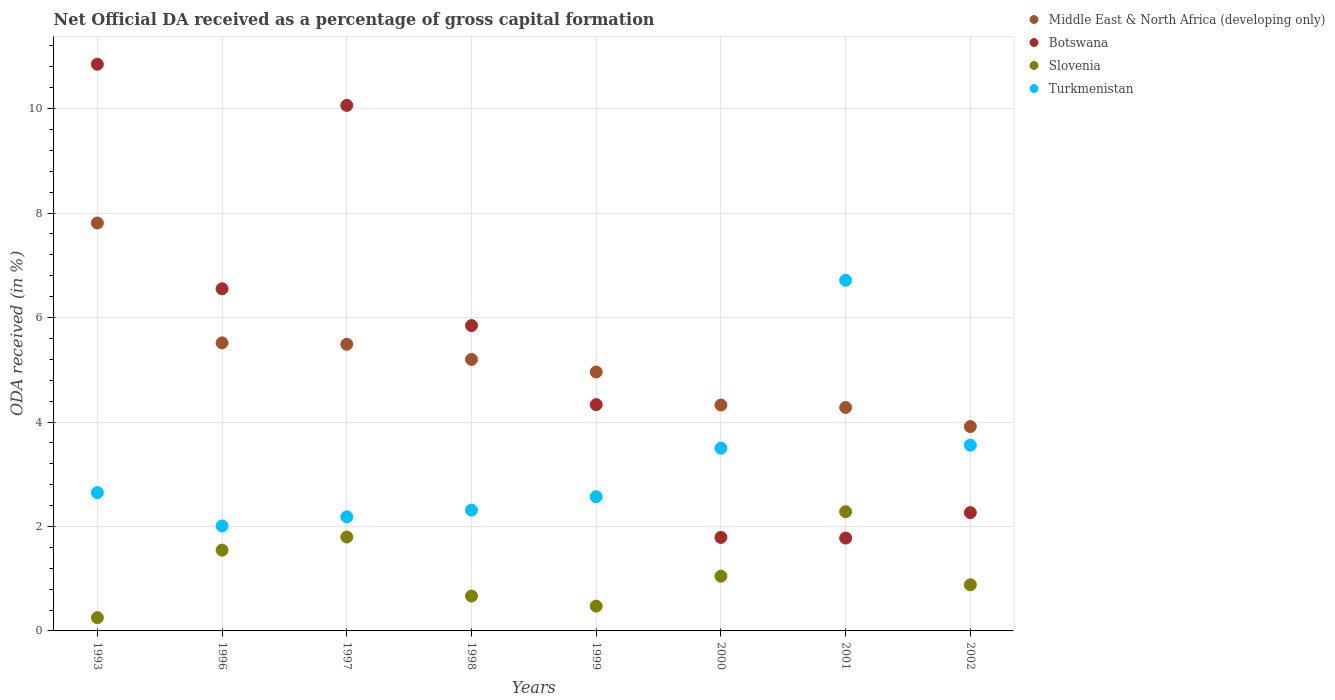Is the number of dotlines equal to the number of legend labels?
Your answer should be very brief. Yes. What is the net ODA received in Slovenia in 1993?
Your answer should be compact. 0.25. Across all years, what is the maximum net ODA received in Middle East & North Africa (developing only)?
Make the answer very short. 7.81. Across all years, what is the minimum net ODA received in Turkmenistan?
Provide a short and direct response. 2.01. In which year was the net ODA received in Middle East & North Africa (developing only) maximum?
Make the answer very short. 1993. In which year was the net ODA received in Turkmenistan minimum?
Provide a short and direct response. 1996. What is the total net ODA received in Slovenia in the graph?
Make the answer very short. 8.95. What is the difference between the net ODA received in Botswana in 1997 and that in 1998?
Ensure brevity in your answer.  4.22. What is the difference between the net ODA received in Middle East & North Africa (developing only) in 1993 and the net ODA received in Botswana in 2002?
Keep it short and to the point. 5.55. What is the average net ODA received in Turkmenistan per year?
Give a very brief answer. 3.19. In the year 1998, what is the difference between the net ODA received in Slovenia and net ODA received in Botswana?
Keep it short and to the point. -5.18. What is the ratio of the net ODA received in Slovenia in 1996 to that in 2000?
Keep it short and to the point. 1.48. Is the difference between the net ODA received in Slovenia in 1997 and 2001 greater than the difference between the net ODA received in Botswana in 1997 and 2001?
Keep it short and to the point. No. What is the difference between the highest and the second highest net ODA received in Slovenia?
Provide a succinct answer. 0.48. What is the difference between the highest and the lowest net ODA received in Turkmenistan?
Your response must be concise. 4.7. Is it the case that in every year, the sum of the net ODA received in Middle East & North Africa (developing only) and net ODA received in Botswana  is greater than the net ODA received in Slovenia?
Ensure brevity in your answer.  Yes. Is the net ODA received in Turkmenistan strictly greater than the net ODA received in Middle East & North Africa (developing only) over the years?
Make the answer very short. No. How many dotlines are there?
Offer a terse response. 4. What is the difference between two consecutive major ticks on the Y-axis?
Make the answer very short. 2. Are the values on the major ticks of Y-axis written in scientific E-notation?
Offer a terse response. No. Does the graph contain any zero values?
Your answer should be very brief. No. How many legend labels are there?
Your answer should be compact. 4. What is the title of the graph?
Ensure brevity in your answer.  Net Official DA received as a percentage of gross capital formation. What is the label or title of the X-axis?
Your answer should be very brief. Years. What is the label or title of the Y-axis?
Your answer should be compact. ODA received (in %). What is the ODA received (in %) of Middle East & North Africa (developing only) in 1993?
Ensure brevity in your answer.  7.81. What is the ODA received (in %) of Botswana in 1993?
Provide a succinct answer. 10.85. What is the ODA received (in %) of Slovenia in 1993?
Offer a very short reply. 0.25. What is the ODA received (in %) in Turkmenistan in 1993?
Make the answer very short. 2.65. What is the ODA received (in %) of Middle East & North Africa (developing only) in 1996?
Keep it short and to the point. 5.52. What is the ODA received (in %) of Botswana in 1996?
Offer a terse response. 6.55. What is the ODA received (in %) of Slovenia in 1996?
Give a very brief answer. 1.55. What is the ODA received (in %) in Turkmenistan in 1996?
Keep it short and to the point. 2.01. What is the ODA received (in %) of Middle East & North Africa (developing only) in 1997?
Give a very brief answer. 5.49. What is the ODA received (in %) of Botswana in 1997?
Ensure brevity in your answer.  10.06. What is the ODA received (in %) of Slovenia in 1997?
Ensure brevity in your answer.  1.8. What is the ODA received (in %) in Turkmenistan in 1997?
Offer a very short reply. 2.18. What is the ODA received (in %) in Middle East & North Africa (developing only) in 1998?
Give a very brief answer. 5.2. What is the ODA received (in %) of Botswana in 1998?
Provide a short and direct response. 5.85. What is the ODA received (in %) in Slovenia in 1998?
Ensure brevity in your answer.  0.67. What is the ODA received (in %) of Turkmenistan in 1998?
Provide a succinct answer. 2.31. What is the ODA received (in %) of Middle East & North Africa (developing only) in 1999?
Provide a short and direct response. 4.96. What is the ODA received (in %) in Botswana in 1999?
Make the answer very short. 4.33. What is the ODA received (in %) of Slovenia in 1999?
Keep it short and to the point. 0.47. What is the ODA received (in %) in Turkmenistan in 1999?
Make the answer very short. 2.57. What is the ODA received (in %) in Middle East & North Africa (developing only) in 2000?
Make the answer very short. 4.33. What is the ODA received (in %) in Botswana in 2000?
Make the answer very short. 1.79. What is the ODA received (in %) in Slovenia in 2000?
Provide a short and direct response. 1.05. What is the ODA received (in %) in Turkmenistan in 2000?
Give a very brief answer. 3.5. What is the ODA received (in %) of Middle East & North Africa (developing only) in 2001?
Provide a short and direct response. 4.28. What is the ODA received (in %) in Botswana in 2001?
Provide a short and direct response. 1.78. What is the ODA received (in %) of Slovenia in 2001?
Your answer should be very brief. 2.28. What is the ODA received (in %) in Turkmenistan in 2001?
Your response must be concise. 6.71. What is the ODA received (in %) of Middle East & North Africa (developing only) in 2002?
Your response must be concise. 3.91. What is the ODA received (in %) of Botswana in 2002?
Provide a succinct answer. 2.26. What is the ODA received (in %) of Slovenia in 2002?
Ensure brevity in your answer.  0.88. What is the ODA received (in %) of Turkmenistan in 2002?
Offer a terse response. 3.56. Across all years, what is the maximum ODA received (in %) in Middle East & North Africa (developing only)?
Provide a succinct answer. 7.81. Across all years, what is the maximum ODA received (in %) in Botswana?
Your answer should be compact. 10.85. Across all years, what is the maximum ODA received (in %) in Slovenia?
Offer a very short reply. 2.28. Across all years, what is the maximum ODA received (in %) in Turkmenistan?
Keep it short and to the point. 6.71. Across all years, what is the minimum ODA received (in %) in Middle East & North Africa (developing only)?
Provide a short and direct response. 3.91. Across all years, what is the minimum ODA received (in %) in Botswana?
Your answer should be compact. 1.78. Across all years, what is the minimum ODA received (in %) of Slovenia?
Make the answer very short. 0.25. Across all years, what is the minimum ODA received (in %) of Turkmenistan?
Your answer should be compact. 2.01. What is the total ODA received (in %) of Middle East & North Africa (developing only) in the graph?
Your response must be concise. 41.49. What is the total ODA received (in %) in Botswana in the graph?
Your response must be concise. 43.47. What is the total ODA received (in %) of Slovenia in the graph?
Provide a succinct answer. 8.95. What is the total ODA received (in %) of Turkmenistan in the graph?
Your answer should be compact. 25.49. What is the difference between the ODA received (in %) of Middle East & North Africa (developing only) in 1993 and that in 1996?
Ensure brevity in your answer.  2.29. What is the difference between the ODA received (in %) in Botswana in 1993 and that in 1996?
Keep it short and to the point. 4.3. What is the difference between the ODA received (in %) in Slovenia in 1993 and that in 1996?
Your response must be concise. -1.29. What is the difference between the ODA received (in %) of Turkmenistan in 1993 and that in 1996?
Offer a terse response. 0.64. What is the difference between the ODA received (in %) in Middle East & North Africa (developing only) in 1993 and that in 1997?
Offer a very short reply. 2.32. What is the difference between the ODA received (in %) in Botswana in 1993 and that in 1997?
Keep it short and to the point. 0.79. What is the difference between the ODA received (in %) of Slovenia in 1993 and that in 1997?
Offer a very short reply. -1.54. What is the difference between the ODA received (in %) of Turkmenistan in 1993 and that in 1997?
Offer a terse response. 0.46. What is the difference between the ODA received (in %) of Middle East & North Africa (developing only) in 1993 and that in 1998?
Make the answer very short. 2.61. What is the difference between the ODA received (in %) of Botswana in 1993 and that in 1998?
Offer a terse response. 5. What is the difference between the ODA received (in %) of Slovenia in 1993 and that in 1998?
Provide a short and direct response. -0.41. What is the difference between the ODA received (in %) of Turkmenistan in 1993 and that in 1998?
Offer a very short reply. 0.34. What is the difference between the ODA received (in %) in Middle East & North Africa (developing only) in 1993 and that in 1999?
Offer a very short reply. 2.85. What is the difference between the ODA received (in %) of Botswana in 1993 and that in 1999?
Give a very brief answer. 6.52. What is the difference between the ODA received (in %) of Slovenia in 1993 and that in 1999?
Give a very brief answer. -0.22. What is the difference between the ODA received (in %) of Turkmenistan in 1993 and that in 1999?
Provide a succinct answer. 0.08. What is the difference between the ODA received (in %) in Middle East & North Africa (developing only) in 1993 and that in 2000?
Keep it short and to the point. 3.49. What is the difference between the ODA received (in %) in Botswana in 1993 and that in 2000?
Offer a terse response. 9.06. What is the difference between the ODA received (in %) in Slovenia in 1993 and that in 2000?
Give a very brief answer. -0.79. What is the difference between the ODA received (in %) in Turkmenistan in 1993 and that in 2000?
Your answer should be very brief. -0.85. What is the difference between the ODA received (in %) in Middle East & North Africa (developing only) in 1993 and that in 2001?
Provide a short and direct response. 3.53. What is the difference between the ODA received (in %) in Botswana in 1993 and that in 2001?
Your answer should be compact. 9.07. What is the difference between the ODA received (in %) of Slovenia in 1993 and that in 2001?
Provide a short and direct response. -2.03. What is the difference between the ODA received (in %) of Turkmenistan in 1993 and that in 2001?
Make the answer very short. -4.07. What is the difference between the ODA received (in %) of Middle East & North Africa (developing only) in 1993 and that in 2002?
Make the answer very short. 3.9. What is the difference between the ODA received (in %) in Botswana in 1993 and that in 2002?
Offer a terse response. 8.59. What is the difference between the ODA received (in %) in Slovenia in 1993 and that in 2002?
Provide a succinct answer. -0.63. What is the difference between the ODA received (in %) of Turkmenistan in 1993 and that in 2002?
Provide a short and direct response. -0.91. What is the difference between the ODA received (in %) of Middle East & North Africa (developing only) in 1996 and that in 1997?
Your response must be concise. 0.03. What is the difference between the ODA received (in %) in Botswana in 1996 and that in 1997?
Ensure brevity in your answer.  -3.51. What is the difference between the ODA received (in %) in Slovenia in 1996 and that in 1997?
Provide a succinct answer. -0.25. What is the difference between the ODA received (in %) in Turkmenistan in 1996 and that in 1997?
Offer a terse response. -0.17. What is the difference between the ODA received (in %) of Middle East & North Africa (developing only) in 1996 and that in 1998?
Your answer should be very brief. 0.32. What is the difference between the ODA received (in %) of Botswana in 1996 and that in 1998?
Your answer should be very brief. 0.7. What is the difference between the ODA received (in %) in Slovenia in 1996 and that in 1998?
Make the answer very short. 0.88. What is the difference between the ODA received (in %) of Turkmenistan in 1996 and that in 1998?
Your response must be concise. -0.3. What is the difference between the ODA received (in %) of Middle East & North Africa (developing only) in 1996 and that in 1999?
Ensure brevity in your answer.  0.56. What is the difference between the ODA received (in %) of Botswana in 1996 and that in 1999?
Your answer should be compact. 2.22. What is the difference between the ODA received (in %) in Slovenia in 1996 and that in 1999?
Offer a terse response. 1.07. What is the difference between the ODA received (in %) in Turkmenistan in 1996 and that in 1999?
Offer a terse response. -0.56. What is the difference between the ODA received (in %) of Middle East & North Africa (developing only) in 1996 and that in 2000?
Provide a succinct answer. 1.19. What is the difference between the ODA received (in %) in Botswana in 1996 and that in 2000?
Give a very brief answer. 4.76. What is the difference between the ODA received (in %) in Slovenia in 1996 and that in 2000?
Offer a terse response. 0.5. What is the difference between the ODA received (in %) of Turkmenistan in 1996 and that in 2000?
Your answer should be very brief. -1.49. What is the difference between the ODA received (in %) in Middle East & North Africa (developing only) in 1996 and that in 2001?
Ensure brevity in your answer.  1.24. What is the difference between the ODA received (in %) in Botswana in 1996 and that in 2001?
Ensure brevity in your answer.  4.77. What is the difference between the ODA received (in %) in Slovenia in 1996 and that in 2001?
Give a very brief answer. -0.74. What is the difference between the ODA received (in %) of Turkmenistan in 1996 and that in 2001?
Your response must be concise. -4.7. What is the difference between the ODA received (in %) in Middle East & North Africa (developing only) in 1996 and that in 2002?
Keep it short and to the point. 1.6. What is the difference between the ODA received (in %) in Botswana in 1996 and that in 2002?
Offer a very short reply. 4.29. What is the difference between the ODA received (in %) in Slovenia in 1996 and that in 2002?
Provide a succinct answer. 0.66. What is the difference between the ODA received (in %) of Turkmenistan in 1996 and that in 2002?
Provide a short and direct response. -1.55. What is the difference between the ODA received (in %) of Middle East & North Africa (developing only) in 1997 and that in 1998?
Ensure brevity in your answer.  0.29. What is the difference between the ODA received (in %) in Botswana in 1997 and that in 1998?
Keep it short and to the point. 4.22. What is the difference between the ODA received (in %) of Slovenia in 1997 and that in 1998?
Provide a short and direct response. 1.13. What is the difference between the ODA received (in %) of Turkmenistan in 1997 and that in 1998?
Keep it short and to the point. -0.13. What is the difference between the ODA received (in %) of Middle East & North Africa (developing only) in 1997 and that in 1999?
Provide a succinct answer. 0.53. What is the difference between the ODA received (in %) of Botswana in 1997 and that in 1999?
Your answer should be compact. 5.73. What is the difference between the ODA received (in %) in Slovenia in 1997 and that in 1999?
Give a very brief answer. 1.32. What is the difference between the ODA received (in %) in Turkmenistan in 1997 and that in 1999?
Give a very brief answer. -0.39. What is the difference between the ODA received (in %) in Middle East & North Africa (developing only) in 1997 and that in 2000?
Provide a succinct answer. 1.16. What is the difference between the ODA received (in %) in Botswana in 1997 and that in 2000?
Your answer should be very brief. 8.27. What is the difference between the ODA received (in %) in Slovenia in 1997 and that in 2000?
Give a very brief answer. 0.75. What is the difference between the ODA received (in %) of Turkmenistan in 1997 and that in 2000?
Provide a succinct answer. -1.31. What is the difference between the ODA received (in %) in Middle East & North Africa (developing only) in 1997 and that in 2001?
Offer a very short reply. 1.21. What is the difference between the ODA received (in %) in Botswana in 1997 and that in 2001?
Your answer should be compact. 8.28. What is the difference between the ODA received (in %) of Slovenia in 1997 and that in 2001?
Provide a succinct answer. -0.48. What is the difference between the ODA received (in %) of Turkmenistan in 1997 and that in 2001?
Offer a terse response. -4.53. What is the difference between the ODA received (in %) of Middle East & North Africa (developing only) in 1997 and that in 2002?
Offer a terse response. 1.58. What is the difference between the ODA received (in %) in Botswana in 1997 and that in 2002?
Give a very brief answer. 7.8. What is the difference between the ODA received (in %) in Slovenia in 1997 and that in 2002?
Your answer should be very brief. 0.91. What is the difference between the ODA received (in %) in Turkmenistan in 1997 and that in 2002?
Your answer should be very brief. -1.37. What is the difference between the ODA received (in %) in Middle East & North Africa (developing only) in 1998 and that in 1999?
Make the answer very short. 0.24. What is the difference between the ODA received (in %) of Botswana in 1998 and that in 1999?
Keep it short and to the point. 1.51. What is the difference between the ODA received (in %) of Slovenia in 1998 and that in 1999?
Offer a very short reply. 0.19. What is the difference between the ODA received (in %) in Turkmenistan in 1998 and that in 1999?
Your answer should be compact. -0.26. What is the difference between the ODA received (in %) in Middle East & North Africa (developing only) in 1998 and that in 2000?
Ensure brevity in your answer.  0.87. What is the difference between the ODA received (in %) in Botswana in 1998 and that in 2000?
Make the answer very short. 4.06. What is the difference between the ODA received (in %) in Slovenia in 1998 and that in 2000?
Offer a terse response. -0.38. What is the difference between the ODA received (in %) in Turkmenistan in 1998 and that in 2000?
Your response must be concise. -1.19. What is the difference between the ODA received (in %) in Middle East & North Africa (developing only) in 1998 and that in 2001?
Your answer should be compact. 0.92. What is the difference between the ODA received (in %) in Botswana in 1998 and that in 2001?
Offer a terse response. 4.07. What is the difference between the ODA received (in %) of Slovenia in 1998 and that in 2001?
Make the answer very short. -1.61. What is the difference between the ODA received (in %) of Turkmenistan in 1998 and that in 2001?
Your response must be concise. -4.4. What is the difference between the ODA received (in %) in Middle East & North Africa (developing only) in 1998 and that in 2002?
Your answer should be very brief. 1.29. What is the difference between the ODA received (in %) of Botswana in 1998 and that in 2002?
Ensure brevity in your answer.  3.58. What is the difference between the ODA received (in %) of Slovenia in 1998 and that in 2002?
Ensure brevity in your answer.  -0.22. What is the difference between the ODA received (in %) of Turkmenistan in 1998 and that in 2002?
Your response must be concise. -1.24. What is the difference between the ODA received (in %) of Middle East & North Africa (developing only) in 1999 and that in 2000?
Provide a short and direct response. 0.63. What is the difference between the ODA received (in %) of Botswana in 1999 and that in 2000?
Give a very brief answer. 2.54. What is the difference between the ODA received (in %) of Slovenia in 1999 and that in 2000?
Your response must be concise. -0.57. What is the difference between the ODA received (in %) of Turkmenistan in 1999 and that in 2000?
Provide a short and direct response. -0.93. What is the difference between the ODA received (in %) of Middle East & North Africa (developing only) in 1999 and that in 2001?
Keep it short and to the point. 0.68. What is the difference between the ODA received (in %) in Botswana in 1999 and that in 2001?
Give a very brief answer. 2.55. What is the difference between the ODA received (in %) of Slovenia in 1999 and that in 2001?
Ensure brevity in your answer.  -1.81. What is the difference between the ODA received (in %) of Turkmenistan in 1999 and that in 2001?
Offer a very short reply. -4.14. What is the difference between the ODA received (in %) of Middle East & North Africa (developing only) in 1999 and that in 2002?
Give a very brief answer. 1.05. What is the difference between the ODA received (in %) of Botswana in 1999 and that in 2002?
Your answer should be very brief. 2.07. What is the difference between the ODA received (in %) in Slovenia in 1999 and that in 2002?
Make the answer very short. -0.41. What is the difference between the ODA received (in %) in Turkmenistan in 1999 and that in 2002?
Ensure brevity in your answer.  -0.99. What is the difference between the ODA received (in %) in Middle East & North Africa (developing only) in 2000 and that in 2001?
Give a very brief answer. 0.05. What is the difference between the ODA received (in %) of Botswana in 2000 and that in 2001?
Offer a very short reply. 0.01. What is the difference between the ODA received (in %) of Slovenia in 2000 and that in 2001?
Your response must be concise. -1.23. What is the difference between the ODA received (in %) in Turkmenistan in 2000 and that in 2001?
Offer a terse response. -3.22. What is the difference between the ODA received (in %) in Middle East & North Africa (developing only) in 2000 and that in 2002?
Provide a succinct answer. 0.41. What is the difference between the ODA received (in %) of Botswana in 2000 and that in 2002?
Provide a succinct answer. -0.47. What is the difference between the ODA received (in %) in Slovenia in 2000 and that in 2002?
Your answer should be very brief. 0.16. What is the difference between the ODA received (in %) of Turkmenistan in 2000 and that in 2002?
Offer a terse response. -0.06. What is the difference between the ODA received (in %) of Middle East & North Africa (developing only) in 2001 and that in 2002?
Offer a terse response. 0.37. What is the difference between the ODA received (in %) of Botswana in 2001 and that in 2002?
Give a very brief answer. -0.49. What is the difference between the ODA received (in %) of Slovenia in 2001 and that in 2002?
Ensure brevity in your answer.  1.4. What is the difference between the ODA received (in %) of Turkmenistan in 2001 and that in 2002?
Offer a terse response. 3.16. What is the difference between the ODA received (in %) in Middle East & North Africa (developing only) in 1993 and the ODA received (in %) in Botswana in 1996?
Offer a terse response. 1.26. What is the difference between the ODA received (in %) of Middle East & North Africa (developing only) in 1993 and the ODA received (in %) of Slovenia in 1996?
Your response must be concise. 6.26. What is the difference between the ODA received (in %) in Middle East & North Africa (developing only) in 1993 and the ODA received (in %) in Turkmenistan in 1996?
Give a very brief answer. 5.8. What is the difference between the ODA received (in %) of Botswana in 1993 and the ODA received (in %) of Slovenia in 1996?
Give a very brief answer. 9.3. What is the difference between the ODA received (in %) of Botswana in 1993 and the ODA received (in %) of Turkmenistan in 1996?
Provide a short and direct response. 8.84. What is the difference between the ODA received (in %) in Slovenia in 1993 and the ODA received (in %) in Turkmenistan in 1996?
Offer a terse response. -1.76. What is the difference between the ODA received (in %) of Middle East & North Africa (developing only) in 1993 and the ODA received (in %) of Botswana in 1997?
Give a very brief answer. -2.25. What is the difference between the ODA received (in %) in Middle East & North Africa (developing only) in 1993 and the ODA received (in %) in Slovenia in 1997?
Give a very brief answer. 6.01. What is the difference between the ODA received (in %) in Middle East & North Africa (developing only) in 1993 and the ODA received (in %) in Turkmenistan in 1997?
Provide a short and direct response. 5.63. What is the difference between the ODA received (in %) of Botswana in 1993 and the ODA received (in %) of Slovenia in 1997?
Provide a succinct answer. 9.05. What is the difference between the ODA received (in %) in Botswana in 1993 and the ODA received (in %) in Turkmenistan in 1997?
Your answer should be compact. 8.67. What is the difference between the ODA received (in %) of Slovenia in 1993 and the ODA received (in %) of Turkmenistan in 1997?
Ensure brevity in your answer.  -1.93. What is the difference between the ODA received (in %) of Middle East & North Africa (developing only) in 1993 and the ODA received (in %) of Botswana in 1998?
Your answer should be compact. 1.96. What is the difference between the ODA received (in %) of Middle East & North Africa (developing only) in 1993 and the ODA received (in %) of Slovenia in 1998?
Keep it short and to the point. 7.14. What is the difference between the ODA received (in %) in Middle East & North Africa (developing only) in 1993 and the ODA received (in %) in Turkmenistan in 1998?
Ensure brevity in your answer.  5.5. What is the difference between the ODA received (in %) of Botswana in 1993 and the ODA received (in %) of Slovenia in 1998?
Your response must be concise. 10.18. What is the difference between the ODA received (in %) in Botswana in 1993 and the ODA received (in %) in Turkmenistan in 1998?
Give a very brief answer. 8.54. What is the difference between the ODA received (in %) of Slovenia in 1993 and the ODA received (in %) of Turkmenistan in 1998?
Your answer should be very brief. -2.06. What is the difference between the ODA received (in %) of Middle East & North Africa (developing only) in 1993 and the ODA received (in %) of Botswana in 1999?
Your answer should be compact. 3.48. What is the difference between the ODA received (in %) of Middle East & North Africa (developing only) in 1993 and the ODA received (in %) of Slovenia in 1999?
Offer a terse response. 7.34. What is the difference between the ODA received (in %) of Middle East & North Africa (developing only) in 1993 and the ODA received (in %) of Turkmenistan in 1999?
Provide a short and direct response. 5.24. What is the difference between the ODA received (in %) in Botswana in 1993 and the ODA received (in %) in Slovenia in 1999?
Provide a succinct answer. 10.38. What is the difference between the ODA received (in %) of Botswana in 1993 and the ODA received (in %) of Turkmenistan in 1999?
Your response must be concise. 8.28. What is the difference between the ODA received (in %) in Slovenia in 1993 and the ODA received (in %) in Turkmenistan in 1999?
Provide a succinct answer. -2.32. What is the difference between the ODA received (in %) in Middle East & North Africa (developing only) in 1993 and the ODA received (in %) in Botswana in 2000?
Ensure brevity in your answer.  6.02. What is the difference between the ODA received (in %) in Middle East & North Africa (developing only) in 1993 and the ODA received (in %) in Slovenia in 2000?
Ensure brevity in your answer.  6.76. What is the difference between the ODA received (in %) in Middle East & North Africa (developing only) in 1993 and the ODA received (in %) in Turkmenistan in 2000?
Your answer should be very brief. 4.31. What is the difference between the ODA received (in %) of Botswana in 1993 and the ODA received (in %) of Slovenia in 2000?
Offer a terse response. 9.8. What is the difference between the ODA received (in %) of Botswana in 1993 and the ODA received (in %) of Turkmenistan in 2000?
Make the answer very short. 7.35. What is the difference between the ODA received (in %) in Slovenia in 1993 and the ODA received (in %) in Turkmenistan in 2000?
Keep it short and to the point. -3.24. What is the difference between the ODA received (in %) of Middle East & North Africa (developing only) in 1993 and the ODA received (in %) of Botswana in 2001?
Provide a succinct answer. 6.03. What is the difference between the ODA received (in %) in Middle East & North Africa (developing only) in 1993 and the ODA received (in %) in Slovenia in 2001?
Your response must be concise. 5.53. What is the difference between the ODA received (in %) of Middle East & North Africa (developing only) in 1993 and the ODA received (in %) of Turkmenistan in 2001?
Offer a terse response. 1.1. What is the difference between the ODA received (in %) in Botswana in 1993 and the ODA received (in %) in Slovenia in 2001?
Provide a short and direct response. 8.57. What is the difference between the ODA received (in %) in Botswana in 1993 and the ODA received (in %) in Turkmenistan in 2001?
Give a very brief answer. 4.14. What is the difference between the ODA received (in %) of Slovenia in 1993 and the ODA received (in %) of Turkmenistan in 2001?
Offer a terse response. -6.46. What is the difference between the ODA received (in %) of Middle East & North Africa (developing only) in 1993 and the ODA received (in %) of Botswana in 2002?
Keep it short and to the point. 5.55. What is the difference between the ODA received (in %) in Middle East & North Africa (developing only) in 1993 and the ODA received (in %) in Slovenia in 2002?
Offer a very short reply. 6.93. What is the difference between the ODA received (in %) in Middle East & North Africa (developing only) in 1993 and the ODA received (in %) in Turkmenistan in 2002?
Ensure brevity in your answer.  4.25. What is the difference between the ODA received (in %) in Botswana in 1993 and the ODA received (in %) in Slovenia in 2002?
Give a very brief answer. 9.97. What is the difference between the ODA received (in %) of Botswana in 1993 and the ODA received (in %) of Turkmenistan in 2002?
Keep it short and to the point. 7.29. What is the difference between the ODA received (in %) of Slovenia in 1993 and the ODA received (in %) of Turkmenistan in 2002?
Provide a succinct answer. -3.3. What is the difference between the ODA received (in %) of Middle East & North Africa (developing only) in 1996 and the ODA received (in %) of Botswana in 1997?
Keep it short and to the point. -4.55. What is the difference between the ODA received (in %) of Middle East & North Africa (developing only) in 1996 and the ODA received (in %) of Slovenia in 1997?
Your response must be concise. 3.72. What is the difference between the ODA received (in %) of Middle East & North Africa (developing only) in 1996 and the ODA received (in %) of Turkmenistan in 1997?
Your response must be concise. 3.33. What is the difference between the ODA received (in %) in Botswana in 1996 and the ODA received (in %) in Slovenia in 1997?
Keep it short and to the point. 4.75. What is the difference between the ODA received (in %) in Botswana in 1996 and the ODA received (in %) in Turkmenistan in 1997?
Offer a terse response. 4.37. What is the difference between the ODA received (in %) in Slovenia in 1996 and the ODA received (in %) in Turkmenistan in 1997?
Offer a terse response. -0.64. What is the difference between the ODA received (in %) of Middle East & North Africa (developing only) in 1996 and the ODA received (in %) of Botswana in 1998?
Your response must be concise. -0.33. What is the difference between the ODA received (in %) in Middle East & North Africa (developing only) in 1996 and the ODA received (in %) in Slovenia in 1998?
Offer a very short reply. 4.85. What is the difference between the ODA received (in %) in Middle East & North Africa (developing only) in 1996 and the ODA received (in %) in Turkmenistan in 1998?
Make the answer very short. 3.2. What is the difference between the ODA received (in %) of Botswana in 1996 and the ODA received (in %) of Slovenia in 1998?
Give a very brief answer. 5.88. What is the difference between the ODA received (in %) of Botswana in 1996 and the ODA received (in %) of Turkmenistan in 1998?
Your answer should be very brief. 4.24. What is the difference between the ODA received (in %) in Slovenia in 1996 and the ODA received (in %) in Turkmenistan in 1998?
Offer a very short reply. -0.77. What is the difference between the ODA received (in %) of Middle East & North Africa (developing only) in 1996 and the ODA received (in %) of Botswana in 1999?
Your answer should be compact. 1.18. What is the difference between the ODA received (in %) in Middle East & North Africa (developing only) in 1996 and the ODA received (in %) in Slovenia in 1999?
Offer a terse response. 5.04. What is the difference between the ODA received (in %) of Middle East & North Africa (developing only) in 1996 and the ODA received (in %) of Turkmenistan in 1999?
Provide a short and direct response. 2.95. What is the difference between the ODA received (in %) of Botswana in 1996 and the ODA received (in %) of Slovenia in 1999?
Offer a terse response. 6.08. What is the difference between the ODA received (in %) of Botswana in 1996 and the ODA received (in %) of Turkmenistan in 1999?
Your response must be concise. 3.98. What is the difference between the ODA received (in %) of Slovenia in 1996 and the ODA received (in %) of Turkmenistan in 1999?
Make the answer very short. -1.02. What is the difference between the ODA received (in %) in Middle East & North Africa (developing only) in 1996 and the ODA received (in %) in Botswana in 2000?
Your answer should be very brief. 3.73. What is the difference between the ODA received (in %) in Middle East & North Africa (developing only) in 1996 and the ODA received (in %) in Slovenia in 2000?
Provide a short and direct response. 4.47. What is the difference between the ODA received (in %) of Middle East & North Africa (developing only) in 1996 and the ODA received (in %) of Turkmenistan in 2000?
Provide a succinct answer. 2.02. What is the difference between the ODA received (in %) in Botswana in 1996 and the ODA received (in %) in Slovenia in 2000?
Provide a succinct answer. 5.5. What is the difference between the ODA received (in %) in Botswana in 1996 and the ODA received (in %) in Turkmenistan in 2000?
Offer a terse response. 3.05. What is the difference between the ODA received (in %) of Slovenia in 1996 and the ODA received (in %) of Turkmenistan in 2000?
Make the answer very short. -1.95. What is the difference between the ODA received (in %) in Middle East & North Africa (developing only) in 1996 and the ODA received (in %) in Botswana in 2001?
Your response must be concise. 3.74. What is the difference between the ODA received (in %) of Middle East & North Africa (developing only) in 1996 and the ODA received (in %) of Slovenia in 2001?
Keep it short and to the point. 3.23. What is the difference between the ODA received (in %) in Middle East & North Africa (developing only) in 1996 and the ODA received (in %) in Turkmenistan in 2001?
Provide a short and direct response. -1.2. What is the difference between the ODA received (in %) in Botswana in 1996 and the ODA received (in %) in Slovenia in 2001?
Ensure brevity in your answer.  4.27. What is the difference between the ODA received (in %) in Botswana in 1996 and the ODA received (in %) in Turkmenistan in 2001?
Make the answer very short. -0.16. What is the difference between the ODA received (in %) of Slovenia in 1996 and the ODA received (in %) of Turkmenistan in 2001?
Your answer should be compact. -5.17. What is the difference between the ODA received (in %) of Middle East & North Africa (developing only) in 1996 and the ODA received (in %) of Botswana in 2002?
Provide a succinct answer. 3.25. What is the difference between the ODA received (in %) in Middle East & North Africa (developing only) in 1996 and the ODA received (in %) in Slovenia in 2002?
Give a very brief answer. 4.63. What is the difference between the ODA received (in %) of Middle East & North Africa (developing only) in 1996 and the ODA received (in %) of Turkmenistan in 2002?
Offer a very short reply. 1.96. What is the difference between the ODA received (in %) in Botswana in 1996 and the ODA received (in %) in Slovenia in 2002?
Provide a short and direct response. 5.67. What is the difference between the ODA received (in %) in Botswana in 1996 and the ODA received (in %) in Turkmenistan in 2002?
Provide a short and direct response. 2.99. What is the difference between the ODA received (in %) of Slovenia in 1996 and the ODA received (in %) of Turkmenistan in 2002?
Offer a very short reply. -2.01. What is the difference between the ODA received (in %) in Middle East & North Africa (developing only) in 1997 and the ODA received (in %) in Botswana in 1998?
Offer a very short reply. -0.36. What is the difference between the ODA received (in %) in Middle East & North Africa (developing only) in 1997 and the ODA received (in %) in Slovenia in 1998?
Your answer should be very brief. 4.82. What is the difference between the ODA received (in %) of Middle East & North Africa (developing only) in 1997 and the ODA received (in %) of Turkmenistan in 1998?
Provide a succinct answer. 3.18. What is the difference between the ODA received (in %) in Botswana in 1997 and the ODA received (in %) in Slovenia in 1998?
Ensure brevity in your answer.  9.39. What is the difference between the ODA received (in %) of Botswana in 1997 and the ODA received (in %) of Turkmenistan in 1998?
Your response must be concise. 7.75. What is the difference between the ODA received (in %) in Slovenia in 1997 and the ODA received (in %) in Turkmenistan in 1998?
Provide a succinct answer. -0.51. What is the difference between the ODA received (in %) of Middle East & North Africa (developing only) in 1997 and the ODA received (in %) of Botswana in 1999?
Keep it short and to the point. 1.16. What is the difference between the ODA received (in %) of Middle East & North Africa (developing only) in 1997 and the ODA received (in %) of Slovenia in 1999?
Offer a very short reply. 5.01. What is the difference between the ODA received (in %) of Middle East & North Africa (developing only) in 1997 and the ODA received (in %) of Turkmenistan in 1999?
Provide a succinct answer. 2.92. What is the difference between the ODA received (in %) of Botswana in 1997 and the ODA received (in %) of Slovenia in 1999?
Provide a short and direct response. 9.59. What is the difference between the ODA received (in %) of Botswana in 1997 and the ODA received (in %) of Turkmenistan in 1999?
Ensure brevity in your answer.  7.49. What is the difference between the ODA received (in %) in Slovenia in 1997 and the ODA received (in %) in Turkmenistan in 1999?
Provide a short and direct response. -0.77. What is the difference between the ODA received (in %) of Middle East & North Africa (developing only) in 1997 and the ODA received (in %) of Botswana in 2000?
Give a very brief answer. 3.7. What is the difference between the ODA received (in %) in Middle East & North Africa (developing only) in 1997 and the ODA received (in %) in Slovenia in 2000?
Offer a very short reply. 4.44. What is the difference between the ODA received (in %) of Middle East & North Africa (developing only) in 1997 and the ODA received (in %) of Turkmenistan in 2000?
Offer a terse response. 1.99. What is the difference between the ODA received (in %) of Botswana in 1997 and the ODA received (in %) of Slovenia in 2000?
Provide a succinct answer. 9.01. What is the difference between the ODA received (in %) of Botswana in 1997 and the ODA received (in %) of Turkmenistan in 2000?
Your response must be concise. 6.56. What is the difference between the ODA received (in %) of Slovenia in 1997 and the ODA received (in %) of Turkmenistan in 2000?
Make the answer very short. -1.7. What is the difference between the ODA received (in %) in Middle East & North Africa (developing only) in 1997 and the ODA received (in %) in Botswana in 2001?
Make the answer very short. 3.71. What is the difference between the ODA received (in %) in Middle East & North Africa (developing only) in 1997 and the ODA received (in %) in Slovenia in 2001?
Offer a terse response. 3.21. What is the difference between the ODA received (in %) in Middle East & North Africa (developing only) in 1997 and the ODA received (in %) in Turkmenistan in 2001?
Offer a terse response. -1.23. What is the difference between the ODA received (in %) of Botswana in 1997 and the ODA received (in %) of Slovenia in 2001?
Your response must be concise. 7.78. What is the difference between the ODA received (in %) in Botswana in 1997 and the ODA received (in %) in Turkmenistan in 2001?
Provide a short and direct response. 3.35. What is the difference between the ODA received (in %) of Slovenia in 1997 and the ODA received (in %) of Turkmenistan in 2001?
Give a very brief answer. -4.92. What is the difference between the ODA received (in %) of Middle East & North Africa (developing only) in 1997 and the ODA received (in %) of Botswana in 2002?
Offer a terse response. 3.22. What is the difference between the ODA received (in %) of Middle East & North Africa (developing only) in 1997 and the ODA received (in %) of Slovenia in 2002?
Keep it short and to the point. 4.6. What is the difference between the ODA received (in %) of Middle East & North Africa (developing only) in 1997 and the ODA received (in %) of Turkmenistan in 2002?
Keep it short and to the point. 1.93. What is the difference between the ODA received (in %) in Botswana in 1997 and the ODA received (in %) in Slovenia in 2002?
Your answer should be compact. 9.18. What is the difference between the ODA received (in %) of Botswana in 1997 and the ODA received (in %) of Turkmenistan in 2002?
Your answer should be compact. 6.51. What is the difference between the ODA received (in %) of Slovenia in 1997 and the ODA received (in %) of Turkmenistan in 2002?
Ensure brevity in your answer.  -1.76. What is the difference between the ODA received (in %) of Middle East & North Africa (developing only) in 1998 and the ODA received (in %) of Botswana in 1999?
Offer a terse response. 0.87. What is the difference between the ODA received (in %) in Middle East & North Africa (developing only) in 1998 and the ODA received (in %) in Slovenia in 1999?
Ensure brevity in your answer.  4.72. What is the difference between the ODA received (in %) in Middle East & North Africa (developing only) in 1998 and the ODA received (in %) in Turkmenistan in 1999?
Give a very brief answer. 2.63. What is the difference between the ODA received (in %) of Botswana in 1998 and the ODA received (in %) of Slovenia in 1999?
Provide a succinct answer. 5.37. What is the difference between the ODA received (in %) of Botswana in 1998 and the ODA received (in %) of Turkmenistan in 1999?
Offer a terse response. 3.28. What is the difference between the ODA received (in %) in Slovenia in 1998 and the ODA received (in %) in Turkmenistan in 1999?
Provide a succinct answer. -1.9. What is the difference between the ODA received (in %) of Middle East & North Africa (developing only) in 1998 and the ODA received (in %) of Botswana in 2000?
Your answer should be very brief. 3.41. What is the difference between the ODA received (in %) in Middle East & North Africa (developing only) in 1998 and the ODA received (in %) in Slovenia in 2000?
Offer a terse response. 4.15. What is the difference between the ODA received (in %) in Botswana in 1998 and the ODA received (in %) in Slovenia in 2000?
Ensure brevity in your answer.  4.8. What is the difference between the ODA received (in %) in Botswana in 1998 and the ODA received (in %) in Turkmenistan in 2000?
Give a very brief answer. 2.35. What is the difference between the ODA received (in %) in Slovenia in 1998 and the ODA received (in %) in Turkmenistan in 2000?
Your answer should be very brief. -2.83. What is the difference between the ODA received (in %) in Middle East & North Africa (developing only) in 1998 and the ODA received (in %) in Botswana in 2001?
Your answer should be compact. 3.42. What is the difference between the ODA received (in %) in Middle East & North Africa (developing only) in 1998 and the ODA received (in %) in Slovenia in 2001?
Your response must be concise. 2.92. What is the difference between the ODA received (in %) of Middle East & North Africa (developing only) in 1998 and the ODA received (in %) of Turkmenistan in 2001?
Keep it short and to the point. -1.52. What is the difference between the ODA received (in %) of Botswana in 1998 and the ODA received (in %) of Slovenia in 2001?
Provide a short and direct response. 3.56. What is the difference between the ODA received (in %) of Botswana in 1998 and the ODA received (in %) of Turkmenistan in 2001?
Provide a short and direct response. -0.87. What is the difference between the ODA received (in %) of Slovenia in 1998 and the ODA received (in %) of Turkmenistan in 2001?
Give a very brief answer. -6.05. What is the difference between the ODA received (in %) in Middle East & North Africa (developing only) in 1998 and the ODA received (in %) in Botswana in 2002?
Provide a short and direct response. 2.93. What is the difference between the ODA received (in %) in Middle East & North Africa (developing only) in 1998 and the ODA received (in %) in Slovenia in 2002?
Give a very brief answer. 4.32. What is the difference between the ODA received (in %) of Middle East & North Africa (developing only) in 1998 and the ODA received (in %) of Turkmenistan in 2002?
Your response must be concise. 1.64. What is the difference between the ODA received (in %) in Botswana in 1998 and the ODA received (in %) in Slovenia in 2002?
Your answer should be compact. 4.96. What is the difference between the ODA received (in %) in Botswana in 1998 and the ODA received (in %) in Turkmenistan in 2002?
Offer a terse response. 2.29. What is the difference between the ODA received (in %) of Slovenia in 1998 and the ODA received (in %) of Turkmenistan in 2002?
Offer a very short reply. -2.89. What is the difference between the ODA received (in %) in Middle East & North Africa (developing only) in 1999 and the ODA received (in %) in Botswana in 2000?
Provide a succinct answer. 3.17. What is the difference between the ODA received (in %) of Middle East & North Africa (developing only) in 1999 and the ODA received (in %) of Slovenia in 2000?
Your answer should be very brief. 3.91. What is the difference between the ODA received (in %) of Middle East & North Africa (developing only) in 1999 and the ODA received (in %) of Turkmenistan in 2000?
Offer a terse response. 1.46. What is the difference between the ODA received (in %) of Botswana in 1999 and the ODA received (in %) of Slovenia in 2000?
Ensure brevity in your answer.  3.28. What is the difference between the ODA received (in %) in Botswana in 1999 and the ODA received (in %) in Turkmenistan in 2000?
Your answer should be compact. 0.83. What is the difference between the ODA received (in %) of Slovenia in 1999 and the ODA received (in %) of Turkmenistan in 2000?
Give a very brief answer. -3.02. What is the difference between the ODA received (in %) in Middle East & North Africa (developing only) in 1999 and the ODA received (in %) in Botswana in 2001?
Give a very brief answer. 3.18. What is the difference between the ODA received (in %) in Middle East & North Africa (developing only) in 1999 and the ODA received (in %) in Slovenia in 2001?
Offer a very short reply. 2.68. What is the difference between the ODA received (in %) in Middle East & North Africa (developing only) in 1999 and the ODA received (in %) in Turkmenistan in 2001?
Offer a very short reply. -1.76. What is the difference between the ODA received (in %) in Botswana in 1999 and the ODA received (in %) in Slovenia in 2001?
Your answer should be compact. 2.05. What is the difference between the ODA received (in %) in Botswana in 1999 and the ODA received (in %) in Turkmenistan in 2001?
Give a very brief answer. -2.38. What is the difference between the ODA received (in %) in Slovenia in 1999 and the ODA received (in %) in Turkmenistan in 2001?
Provide a succinct answer. -6.24. What is the difference between the ODA received (in %) of Middle East & North Africa (developing only) in 1999 and the ODA received (in %) of Botswana in 2002?
Make the answer very short. 2.69. What is the difference between the ODA received (in %) of Middle East & North Africa (developing only) in 1999 and the ODA received (in %) of Slovenia in 2002?
Keep it short and to the point. 4.07. What is the difference between the ODA received (in %) in Middle East & North Africa (developing only) in 1999 and the ODA received (in %) in Turkmenistan in 2002?
Make the answer very short. 1.4. What is the difference between the ODA received (in %) in Botswana in 1999 and the ODA received (in %) in Slovenia in 2002?
Offer a terse response. 3.45. What is the difference between the ODA received (in %) of Botswana in 1999 and the ODA received (in %) of Turkmenistan in 2002?
Offer a very short reply. 0.78. What is the difference between the ODA received (in %) in Slovenia in 1999 and the ODA received (in %) in Turkmenistan in 2002?
Make the answer very short. -3.08. What is the difference between the ODA received (in %) of Middle East & North Africa (developing only) in 2000 and the ODA received (in %) of Botswana in 2001?
Ensure brevity in your answer.  2.55. What is the difference between the ODA received (in %) in Middle East & North Africa (developing only) in 2000 and the ODA received (in %) in Slovenia in 2001?
Your response must be concise. 2.04. What is the difference between the ODA received (in %) in Middle East & North Africa (developing only) in 2000 and the ODA received (in %) in Turkmenistan in 2001?
Keep it short and to the point. -2.39. What is the difference between the ODA received (in %) in Botswana in 2000 and the ODA received (in %) in Slovenia in 2001?
Give a very brief answer. -0.49. What is the difference between the ODA received (in %) of Botswana in 2000 and the ODA received (in %) of Turkmenistan in 2001?
Your answer should be compact. -4.92. What is the difference between the ODA received (in %) in Slovenia in 2000 and the ODA received (in %) in Turkmenistan in 2001?
Give a very brief answer. -5.67. What is the difference between the ODA received (in %) of Middle East & North Africa (developing only) in 2000 and the ODA received (in %) of Botswana in 2002?
Make the answer very short. 2.06. What is the difference between the ODA received (in %) in Middle East & North Africa (developing only) in 2000 and the ODA received (in %) in Slovenia in 2002?
Give a very brief answer. 3.44. What is the difference between the ODA received (in %) in Middle East & North Africa (developing only) in 2000 and the ODA received (in %) in Turkmenistan in 2002?
Provide a succinct answer. 0.77. What is the difference between the ODA received (in %) in Botswana in 2000 and the ODA received (in %) in Slovenia in 2002?
Ensure brevity in your answer.  0.91. What is the difference between the ODA received (in %) in Botswana in 2000 and the ODA received (in %) in Turkmenistan in 2002?
Keep it short and to the point. -1.77. What is the difference between the ODA received (in %) of Slovenia in 2000 and the ODA received (in %) of Turkmenistan in 2002?
Your answer should be compact. -2.51. What is the difference between the ODA received (in %) of Middle East & North Africa (developing only) in 2001 and the ODA received (in %) of Botswana in 2002?
Offer a very short reply. 2.01. What is the difference between the ODA received (in %) in Middle East & North Africa (developing only) in 2001 and the ODA received (in %) in Slovenia in 2002?
Give a very brief answer. 3.4. What is the difference between the ODA received (in %) of Middle East & North Africa (developing only) in 2001 and the ODA received (in %) of Turkmenistan in 2002?
Make the answer very short. 0.72. What is the difference between the ODA received (in %) in Botswana in 2001 and the ODA received (in %) in Slovenia in 2002?
Provide a succinct answer. 0.89. What is the difference between the ODA received (in %) of Botswana in 2001 and the ODA received (in %) of Turkmenistan in 2002?
Make the answer very short. -1.78. What is the difference between the ODA received (in %) of Slovenia in 2001 and the ODA received (in %) of Turkmenistan in 2002?
Offer a terse response. -1.27. What is the average ODA received (in %) of Middle East & North Africa (developing only) per year?
Ensure brevity in your answer.  5.19. What is the average ODA received (in %) in Botswana per year?
Keep it short and to the point. 5.43. What is the average ODA received (in %) in Slovenia per year?
Give a very brief answer. 1.12. What is the average ODA received (in %) in Turkmenistan per year?
Keep it short and to the point. 3.19. In the year 1993, what is the difference between the ODA received (in %) in Middle East & North Africa (developing only) and ODA received (in %) in Botswana?
Make the answer very short. -3.04. In the year 1993, what is the difference between the ODA received (in %) in Middle East & North Africa (developing only) and ODA received (in %) in Slovenia?
Provide a short and direct response. 7.56. In the year 1993, what is the difference between the ODA received (in %) of Middle East & North Africa (developing only) and ODA received (in %) of Turkmenistan?
Your response must be concise. 5.16. In the year 1993, what is the difference between the ODA received (in %) of Botswana and ODA received (in %) of Slovenia?
Your answer should be very brief. 10.6. In the year 1993, what is the difference between the ODA received (in %) in Botswana and ODA received (in %) in Turkmenistan?
Give a very brief answer. 8.2. In the year 1993, what is the difference between the ODA received (in %) of Slovenia and ODA received (in %) of Turkmenistan?
Provide a succinct answer. -2.39. In the year 1996, what is the difference between the ODA received (in %) of Middle East & North Africa (developing only) and ODA received (in %) of Botswana?
Keep it short and to the point. -1.04. In the year 1996, what is the difference between the ODA received (in %) of Middle East & North Africa (developing only) and ODA received (in %) of Slovenia?
Make the answer very short. 3.97. In the year 1996, what is the difference between the ODA received (in %) of Middle East & North Africa (developing only) and ODA received (in %) of Turkmenistan?
Your answer should be very brief. 3.51. In the year 1996, what is the difference between the ODA received (in %) in Botswana and ODA received (in %) in Slovenia?
Your answer should be compact. 5. In the year 1996, what is the difference between the ODA received (in %) of Botswana and ODA received (in %) of Turkmenistan?
Give a very brief answer. 4.54. In the year 1996, what is the difference between the ODA received (in %) in Slovenia and ODA received (in %) in Turkmenistan?
Make the answer very short. -0.46. In the year 1997, what is the difference between the ODA received (in %) in Middle East & North Africa (developing only) and ODA received (in %) in Botswana?
Your response must be concise. -4.57. In the year 1997, what is the difference between the ODA received (in %) in Middle East & North Africa (developing only) and ODA received (in %) in Slovenia?
Offer a very short reply. 3.69. In the year 1997, what is the difference between the ODA received (in %) in Middle East & North Africa (developing only) and ODA received (in %) in Turkmenistan?
Offer a very short reply. 3.3. In the year 1997, what is the difference between the ODA received (in %) of Botswana and ODA received (in %) of Slovenia?
Your response must be concise. 8.26. In the year 1997, what is the difference between the ODA received (in %) in Botswana and ODA received (in %) in Turkmenistan?
Your answer should be very brief. 7.88. In the year 1997, what is the difference between the ODA received (in %) of Slovenia and ODA received (in %) of Turkmenistan?
Your answer should be compact. -0.39. In the year 1998, what is the difference between the ODA received (in %) of Middle East & North Africa (developing only) and ODA received (in %) of Botswana?
Your answer should be very brief. -0.65. In the year 1998, what is the difference between the ODA received (in %) of Middle East & North Africa (developing only) and ODA received (in %) of Slovenia?
Provide a short and direct response. 4.53. In the year 1998, what is the difference between the ODA received (in %) in Middle East & North Africa (developing only) and ODA received (in %) in Turkmenistan?
Offer a terse response. 2.89. In the year 1998, what is the difference between the ODA received (in %) of Botswana and ODA received (in %) of Slovenia?
Your answer should be compact. 5.18. In the year 1998, what is the difference between the ODA received (in %) in Botswana and ODA received (in %) in Turkmenistan?
Ensure brevity in your answer.  3.53. In the year 1998, what is the difference between the ODA received (in %) in Slovenia and ODA received (in %) in Turkmenistan?
Ensure brevity in your answer.  -1.64. In the year 1999, what is the difference between the ODA received (in %) in Middle East & North Africa (developing only) and ODA received (in %) in Botswana?
Provide a succinct answer. 0.63. In the year 1999, what is the difference between the ODA received (in %) of Middle East & North Africa (developing only) and ODA received (in %) of Slovenia?
Make the answer very short. 4.48. In the year 1999, what is the difference between the ODA received (in %) of Middle East & North Africa (developing only) and ODA received (in %) of Turkmenistan?
Give a very brief answer. 2.39. In the year 1999, what is the difference between the ODA received (in %) of Botswana and ODA received (in %) of Slovenia?
Offer a terse response. 3.86. In the year 1999, what is the difference between the ODA received (in %) of Botswana and ODA received (in %) of Turkmenistan?
Offer a terse response. 1.76. In the year 1999, what is the difference between the ODA received (in %) in Slovenia and ODA received (in %) in Turkmenistan?
Ensure brevity in your answer.  -2.1. In the year 2000, what is the difference between the ODA received (in %) of Middle East & North Africa (developing only) and ODA received (in %) of Botswana?
Offer a terse response. 2.53. In the year 2000, what is the difference between the ODA received (in %) in Middle East & North Africa (developing only) and ODA received (in %) in Slovenia?
Provide a succinct answer. 3.28. In the year 2000, what is the difference between the ODA received (in %) of Middle East & North Africa (developing only) and ODA received (in %) of Turkmenistan?
Keep it short and to the point. 0.83. In the year 2000, what is the difference between the ODA received (in %) of Botswana and ODA received (in %) of Slovenia?
Provide a short and direct response. 0.74. In the year 2000, what is the difference between the ODA received (in %) of Botswana and ODA received (in %) of Turkmenistan?
Offer a very short reply. -1.71. In the year 2000, what is the difference between the ODA received (in %) in Slovenia and ODA received (in %) in Turkmenistan?
Ensure brevity in your answer.  -2.45. In the year 2001, what is the difference between the ODA received (in %) in Middle East & North Africa (developing only) and ODA received (in %) in Botswana?
Give a very brief answer. 2.5. In the year 2001, what is the difference between the ODA received (in %) in Middle East & North Africa (developing only) and ODA received (in %) in Slovenia?
Provide a succinct answer. 2. In the year 2001, what is the difference between the ODA received (in %) in Middle East & North Africa (developing only) and ODA received (in %) in Turkmenistan?
Your response must be concise. -2.44. In the year 2001, what is the difference between the ODA received (in %) of Botswana and ODA received (in %) of Slovenia?
Offer a very short reply. -0.5. In the year 2001, what is the difference between the ODA received (in %) of Botswana and ODA received (in %) of Turkmenistan?
Ensure brevity in your answer.  -4.94. In the year 2001, what is the difference between the ODA received (in %) of Slovenia and ODA received (in %) of Turkmenistan?
Give a very brief answer. -4.43. In the year 2002, what is the difference between the ODA received (in %) in Middle East & North Africa (developing only) and ODA received (in %) in Botswana?
Keep it short and to the point. 1.65. In the year 2002, what is the difference between the ODA received (in %) of Middle East & North Africa (developing only) and ODA received (in %) of Slovenia?
Provide a succinct answer. 3.03. In the year 2002, what is the difference between the ODA received (in %) of Middle East & North Africa (developing only) and ODA received (in %) of Turkmenistan?
Provide a succinct answer. 0.36. In the year 2002, what is the difference between the ODA received (in %) in Botswana and ODA received (in %) in Slovenia?
Ensure brevity in your answer.  1.38. In the year 2002, what is the difference between the ODA received (in %) of Botswana and ODA received (in %) of Turkmenistan?
Offer a very short reply. -1.29. In the year 2002, what is the difference between the ODA received (in %) of Slovenia and ODA received (in %) of Turkmenistan?
Provide a succinct answer. -2.67. What is the ratio of the ODA received (in %) of Middle East & North Africa (developing only) in 1993 to that in 1996?
Offer a very short reply. 1.42. What is the ratio of the ODA received (in %) in Botswana in 1993 to that in 1996?
Offer a terse response. 1.66. What is the ratio of the ODA received (in %) of Slovenia in 1993 to that in 1996?
Give a very brief answer. 0.16. What is the ratio of the ODA received (in %) in Turkmenistan in 1993 to that in 1996?
Make the answer very short. 1.32. What is the ratio of the ODA received (in %) in Middle East & North Africa (developing only) in 1993 to that in 1997?
Offer a very short reply. 1.42. What is the ratio of the ODA received (in %) of Botswana in 1993 to that in 1997?
Offer a terse response. 1.08. What is the ratio of the ODA received (in %) of Slovenia in 1993 to that in 1997?
Keep it short and to the point. 0.14. What is the ratio of the ODA received (in %) in Turkmenistan in 1993 to that in 1997?
Your answer should be compact. 1.21. What is the ratio of the ODA received (in %) in Middle East & North Africa (developing only) in 1993 to that in 1998?
Make the answer very short. 1.5. What is the ratio of the ODA received (in %) of Botswana in 1993 to that in 1998?
Give a very brief answer. 1.86. What is the ratio of the ODA received (in %) of Slovenia in 1993 to that in 1998?
Your answer should be very brief. 0.38. What is the ratio of the ODA received (in %) of Turkmenistan in 1993 to that in 1998?
Make the answer very short. 1.15. What is the ratio of the ODA received (in %) in Middle East & North Africa (developing only) in 1993 to that in 1999?
Give a very brief answer. 1.58. What is the ratio of the ODA received (in %) in Botswana in 1993 to that in 1999?
Provide a short and direct response. 2.5. What is the ratio of the ODA received (in %) in Slovenia in 1993 to that in 1999?
Make the answer very short. 0.54. What is the ratio of the ODA received (in %) in Turkmenistan in 1993 to that in 1999?
Offer a terse response. 1.03. What is the ratio of the ODA received (in %) of Middle East & North Africa (developing only) in 1993 to that in 2000?
Give a very brief answer. 1.81. What is the ratio of the ODA received (in %) in Botswana in 1993 to that in 2000?
Provide a succinct answer. 6.06. What is the ratio of the ODA received (in %) in Slovenia in 1993 to that in 2000?
Provide a short and direct response. 0.24. What is the ratio of the ODA received (in %) in Turkmenistan in 1993 to that in 2000?
Your response must be concise. 0.76. What is the ratio of the ODA received (in %) of Middle East & North Africa (developing only) in 1993 to that in 2001?
Ensure brevity in your answer.  1.83. What is the ratio of the ODA received (in %) in Botswana in 1993 to that in 2001?
Your response must be concise. 6.1. What is the ratio of the ODA received (in %) of Slovenia in 1993 to that in 2001?
Your response must be concise. 0.11. What is the ratio of the ODA received (in %) of Turkmenistan in 1993 to that in 2001?
Your response must be concise. 0.39. What is the ratio of the ODA received (in %) of Middle East & North Africa (developing only) in 1993 to that in 2002?
Ensure brevity in your answer.  2. What is the ratio of the ODA received (in %) of Botswana in 1993 to that in 2002?
Provide a short and direct response. 4.79. What is the ratio of the ODA received (in %) of Slovenia in 1993 to that in 2002?
Keep it short and to the point. 0.29. What is the ratio of the ODA received (in %) in Turkmenistan in 1993 to that in 2002?
Offer a very short reply. 0.74. What is the ratio of the ODA received (in %) of Botswana in 1996 to that in 1997?
Make the answer very short. 0.65. What is the ratio of the ODA received (in %) of Slovenia in 1996 to that in 1997?
Ensure brevity in your answer.  0.86. What is the ratio of the ODA received (in %) in Turkmenistan in 1996 to that in 1997?
Your response must be concise. 0.92. What is the ratio of the ODA received (in %) in Middle East & North Africa (developing only) in 1996 to that in 1998?
Your response must be concise. 1.06. What is the ratio of the ODA received (in %) in Botswana in 1996 to that in 1998?
Give a very brief answer. 1.12. What is the ratio of the ODA received (in %) of Slovenia in 1996 to that in 1998?
Provide a succinct answer. 2.32. What is the ratio of the ODA received (in %) of Turkmenistan in 1996 to that in 1998?
Your answer should be very brief. 0.87. What is the ratio of the ODA received (in %) of Middle East & North Africa (developing only) in 1996 to that in 1999?
Offer a terse response. 1.11. What is the ratio of the ODA received (in %) in Botswana in 1996 to that in 1999?
Give a very brief answer. 1.51. What is the ratio of the ODA received (in %) of Slovenia in 1996 to that in 1999?
Provide a succinct answer. 3.26. What is the ratio of the ODA received (in %) in Turkmenistan in 1996 to that in 1999?
Make the answer very short. 0.78. What is the ratio of the ODA received (in %) of Middle East & North Africa (developing only) in 1996 to that in 2000?
Ensure brevity in your answer.  1.28. What is the ratio of the ODA received (in %) of Botswana in 1996 to that in 2000?
Make the answer very short. 3.66. What is the ratio of the ODA received (in %) in Slovenia in 1996 to that in 2000?
Provide a short and direct response. 1.48. What is the ratio of the ODA received (in %) in Turkmenistan in 1996 to that in 2000?
Make the answer very short. 0.57. What is the ratio of the ODA received (in %) of Middle East & North Africa (developing only) in 1996 to that in 2001?
Your answer should be compact. 1.29. What is the ratio of the ODA received (in %) in Botswana in 1996 to that in 2001?
Your response must be concise. 3.68. What is the ratio of the ODA received (in %) of Slovenia in 1996 to that in 2001?
Your answer should be very brief. 0.68. What is the ratio of the ODA received (in %) of Turkmenistan in 1996 to that in 2001?
Ensure brevity in your answer.  0.3. What is the ratio of the ODA received (in %) of Middle East & North Africa (developing only) in 1996 to that in 2002?
Your answer should be very brief. 1.41. What is the ratio of the ODA received (in %) in Botswana in 1996 to that in 2002?
Provide a succinct answer. 2.89. What is the ratio of the ODA received (in %) of Slovenia in 1996 to that in 2002?
Your answer should be compact. 1.75. What is the ratio of the ODA received (in %) of Turkmenistan in 1996 to that in 2002?
Your response must be concise. 0.57. What is the ratio of the ODA received (in %) of Middle East & North Africa (developing only) in 1997 to that in 1998?
Ensure brevity in your answer.  1.06. What is the ratio of the ODA received (in %) in Botswana in 1997 to that in 1998?
Provide a short and direct response. 1.72. What is the ratio of the ODA received (in %) in Slovenia in 1997 to that in 1998?
Your response must be concise. 2.69. What is the ratio of the ODA received (in %) of Turkmenistan in 1997 to that in 1998?
Provide a succinct answer. 0.94. What is the ratio of the ODA received (in %) in Middle East & North Africa (developing only) in 1997 to that in 1999?
Make the answer very short. 1.11. What is the ratio of the ODA received (in %) in Botswana in 1997 to that in 1999?
Your answer should be compact. 2.32. What is the ratio of the ODA received (in %) in Slovenia in 1997 to that in 1999?
Give a very brief answer. 3.79. What is the ratio of the ODA received (in %) of Middle East & North Africa (developing only) in 1997 to that in 2000?
Your response must be concise. 1.27. What is the ratio of the ODA received (in %) in Botswana in 1997 to that in 2000?
Provide a succinct answer. 5.62. What is the ratio of the ODA received (in %) of Slovenia in 1997 to that in 2000?
Provide a short and direct response. 1.72. What is the ratio of the ODA received (in %) in Turkmenistan in 1997 to that in 2000?
Your response must be concise. 0.62. What is the ratio of the ODA received (in %) in Middle East & North Africa (developing only) in 1997 to that in 2001?
Offer a terse response. 1.28. What is the ratio of the ODA received (in %) of Botswana in 1997 to that in 2001?
Your response must be concise. 5.66. What is the ratio of the ODA received (in %) of Slovenia in 1997 to that in 2001?
Ensure brevity in your answer.  0.79. What is the ratio of the ODA received (in %) of Turkmenistan in 1997 to that in 2001?
Provide a short and direct response. 0.33. What is the ratio of the ODA received (in %) of Middle East & North Africa (developing only) in 1997 to that in 2002?
Provide a succinct answer. 1.4. What is the ratio of the ODA received (in %) in Botswana in 1997 to that in 2002?
Offer a very short reply. 4.44. What is the ratio of the ODA received (in %) in Slovenia in 1997 to that in 2002?
Provide a short and direct response. 2.04. What is the ratio of the ODA received (in %) of Turkmenistan in 1997 to that in 2002?
Your answer should be very brief. 0.61. What is the ratio of the ODA received (in %) of Middle East & North Africa (developing only) in 1998 to that in 1999?
Give a very brief answer. 1.05. What is the ratio of the ODA received (in %) of Botswana in 1998 to that in 1999?
Provide a short and direct response. 1.35. What is the ratio of the ODA received (in %) in Slovenia in 1998 to that in 1999?
Provide a succinct answer. 1.41. What is the ratio of the ODA received (in %) of Turkmenistan in 1998 to that in 1999?
Make the answer very short. 0.9. What is the ratio of the ODA received (in %) of Middle East & North Africa (developing only) in 1998 to that in 2000?
Keep it short and to the point. 1.2. What is the ratio of the ODA received (in %) of Botswana in 1998 to that in 2000?
Give a very brief answer. 3.27. What is the ratio of the ODA received (in %) in Slovenia in 1998 to that in 2000?
Ensure brevity in your answer.  0.64. What is the ratio of the ODA received (in %) of Turkmenistan in 1998 to that in 2000?
Provide a succinct answer. 0.66. What is the ratio of the ODA received (in %) of Middle East & North Africa (developing only) in 1998 to that in 2001?
Provide a succinct answer. 1.22. What is the ratio of the ODA received (in %) in Botswana in 1998 to that in 2001?
Make the answer very short. 3.29. What is the ratio of the ODA received (in %) of Slovenia in 1998 to that in 2001?
Make the answer very short. 0.29. What is the ratio of the ODA received (in %) in Turkmenistan in 1998 to that in 2001?
Offer a terse response. 0.34. What is the ratio of the ODA received (in %) of Middle East & North Africa (developing only) in 1998 to that in 2002?
Provide a succinct answer. 1.33. What is the ratio of the ODA received (in %) of Botswana in 1998 to that in 2002?
Provide a short and direct response. 2.58. What is the ratio of the ODA received (in %) of Slovenia in 1998 to that in 2002?
Keep it short and to the point. 0.76. What is the ratio of the ODA received (in %) in Turkmenistan in 1998 to that in 2002?
Provide a succinct answer. 0.65. What is the ratio of the ODA received (in %) in Middle East & North Africa (developing only) in 1999 to that in 2000?
Ensure brevity in your answer.  1.15. What is the ratio of the ODA received (in %) of Botswana in 1999 to that in 2000?
Your answer should be compact. 2.42. What is the ratio of the ODA received (in %) in Slovenia in 1999 to that in 2000?
Offer a very short reply. 0.45. What is the ratio of the ODA received (in %) of Turkmenistan in 1999 to that in 2000?
Give a very brief answer. 0.73. What is the ratio of the ODA received (in %) of Middle East & North Africa (developing only) in 1999 to that in 2001?
Your response must be concise. 1.16. What is the ratio of the ODA received (in %) of Botswana in 1999 to that in 2001?
Your response must be concise. 2.44. What is the ratio of the ODA received (in %) of Slovenia in 1999 to that in 2001?
Provide a succinct answer. 0.21. What is the ratio of the ODA received (in %) of Turkmenistan in 1999 to that in 2001?
Make the answer very short. 0.38. What is the ratio of the ODA received (in %) in Middle East & North Africa (developing only) in 1999 to that in 2002?
Your answer should be compact. 1.27. What is the ratio of the ODA received (in %) of Botswana in 1999 to that in 2002?
Offer a terse response. 1.91. What is the ratio of the ODA received (in %) of Slovenia in 1999 to that in 2002?
Offer a terse response. 0.54. What is the ratio of the ODA received (in %) of Turkmenistan in 1999 to that in 2002?
Provide a succinct answer. 0.72. What is the ratio of the ODA received (in %) of Middle East & North Africa (developing only) in 2000 to that in 2001?
Your response must be concise. 1.01. What is the ratio of the ODA received (in %) of Slovenia in 2000 to that in 2001?
Your answer should be very brief. 0.46. What is the ratio of the ODA received (in %) in Turkmenistan in 2000 to that in 2001?
Keep it short and to the point. 0.52. What is the ratio of the ODA received (in %) in Middle East & North Africa (developing only) in 2000 to that in 2002?
Ensure brevity in your answer.  1.11. What is the ratio of the ODA received (in %) of Botswana in 2000 to that in 2002?
Offer a terse response. 0.79. What is the ratio of the ODA received (in %) of Slovenia in 2000 to that in 2002?
Provide a succinct answer. 1.19. What is the ratio of the ODA received (in %) in Turkmenistan in 2000 to that in 2002?
Make the answer very short. 0.98. What is the ratio of the ODA received (in %) in Middle East & North Africa (developing only) in 2001 to that in 2002?
Ensure brevity in your answer.  1.09. What is the ratio of the ODA received (in %) in Botswana in 2001 to that in 2002?
Keep it short and to the point. 0.79. What is the ratio of the ODA received (in %) in Slovenia in 2001 to that in 2002?
Your answer should be compact. 2.58. What is the ratio of the ODA received (in %) of Turkmenistan in 2001 to that in 2002?
Provide a succinct answer. 1.89. What is the difference between the highest and the second highest ODA received (in %) in Middle East & North Africa (developing only)?
Provide a succinct answer. 2.29. What is the difference between the highest and the second highest ODA received (in %) of Botswana?
Your answer should be very brief. 0.79. What is the difference between the highest and the second highest ODA received (in %) in Slovenia?
Your answer should be compact. 0.48. What is the difference between the highest and the second highest ODA received (in %) of Turkmenistan?
Keep it short and to the point. 3.16. What is the difference between the highest and the lowest ODA received (in %) of Middle East & North Africa (developing only)?
Offer a terse response. 3.9. What is the difference between the highest and the lowest ODA received (in %) in Botswana?
Give a very brief answer. 9.07. What is the difference between the highest and the lowest ODA received (in %) in Slovenia?
Your answer should be compact. 2.03. What is the difference between the highest and the lowest ODA received (in %) in Turkmenistan?
Provide a succinct answer. 4.7. 